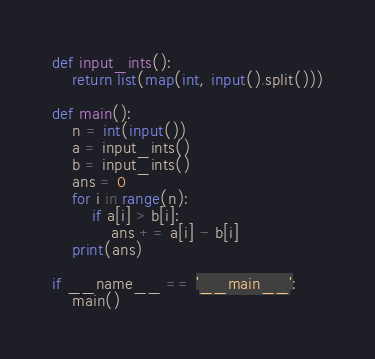Convert code to text. <code><loc_0><loc_0><loc_500><loc_500><_Python_>def input_ints():
    return list(map(int, input().split()))

def main():
    n = int(input())
    a = input_ints()
    b = input_ints()
    ans = 0
    for i in range(n):
        if a[i] > b[i]:
            ans += a[i] - b[i]
    print(ans)

if __name__ == '__main__':
    main()
</code> 